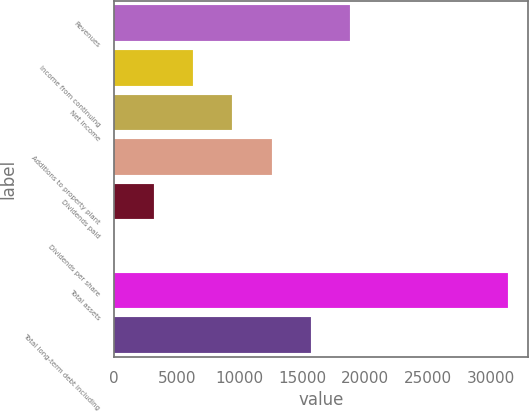Convert chart to OTSL. <chart><loc_0><loc_0><loc_500><loc_500><bar_chart><fcel>Revenues<fcel>Income from continuing<fcel>Net income<fcel>Additions to property plant<fcel>Dividends paid<fcel>Dividends per share<fcel>Total assets<fcel>Total long-term debt including<nl><fcel>18822.9<fcel>6274.84<fcel>9411.86<fcel>12548.9<fcel>3137.82<fcel>0.8<fcel>31371<fcel>15685.9<nl></chart> 